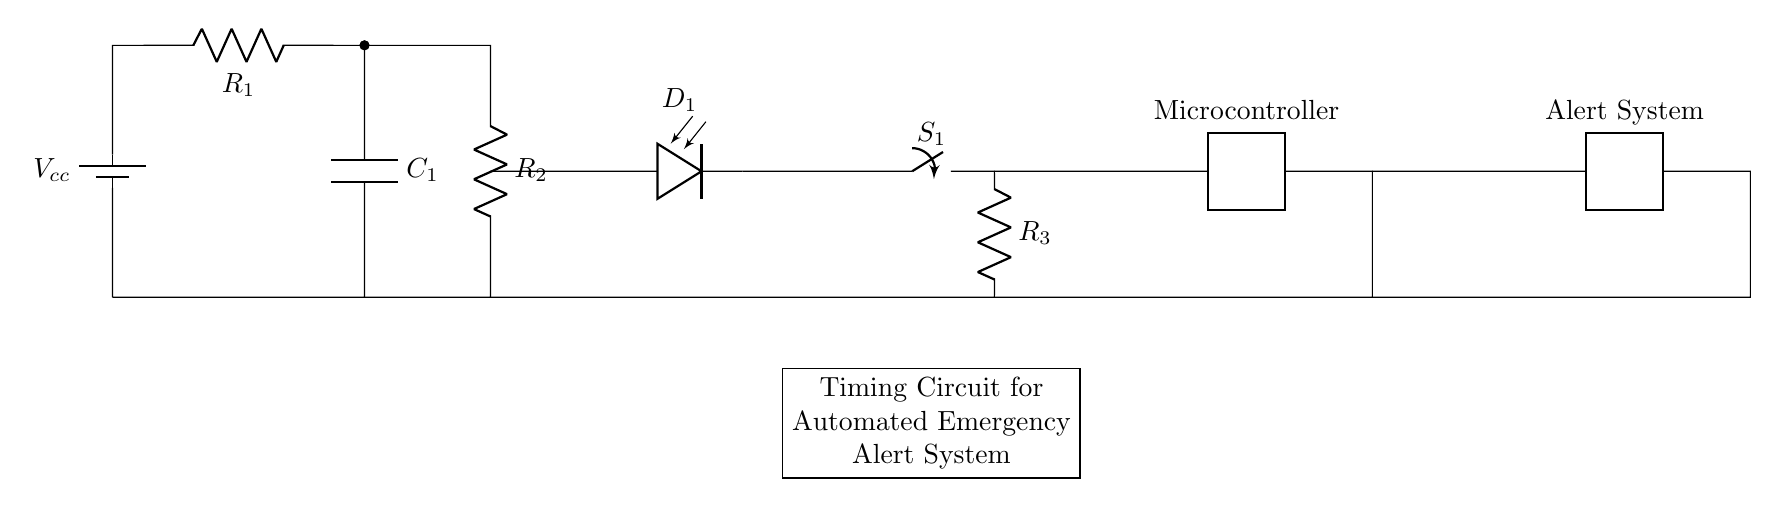What is the power supply voltage in the circuit? The power supply voltage is labeled as Vcc in the circuit and typically indicates the voltage input from the battery, but the exact value is not specified in the visual provided.
Answer: Vcc What component is used to store energy? The component labeled as C1 represents a capacitor, which is commonly used in circuits to store electrical energy.
Answer: Capacitor How many resistors are present in the circuit? There are three resistors labeled R1, R2, and R3. By counting the labels, we can confirm the total number of resistors in the circuit.
Answer: Three What happens when switch S1 is closed? When switch S1 is closed, it completes the circuit allowing current to flow through the circuit, activating the microcontroller and subsequently triggering the alert system.
Answer: Activates alert system Explain the role of the microcontroller. The microcontroller in this circuit acts as a control unit, processing inputs (like the capacitor charge) to decide when to send an alert based on the timing of the circuit. This processing involves controlling the alert system's operation in emergencies.
Answer: Control unit What is the purpose of the diode D1 in the circuit? The diode D1 serves to allow current to flow in one direction only, preventing any backflow that could damage other components, especially when the capacitor discharges or the switch changes state.
Answer: Prevents backflow What is the main function of this timing circuit? The main function of this timing circuit is to trigger an automated alert system during emergencies by utilizing timing elements, notably the capacitor, and managing current flow through the microcontroller and alert system.
Answer: Automated emergency alerts 